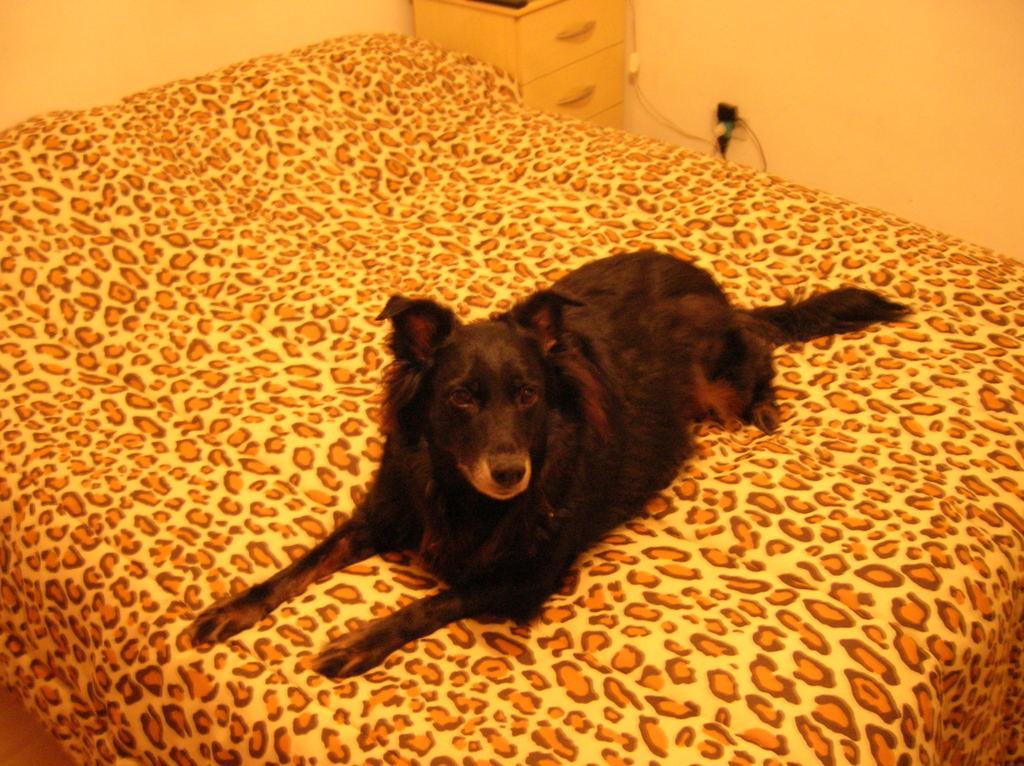Could you give a brief overview of what you see in this image? In the picture we can see a bed, on it we can see a dog which is black in color and in the background, we can see some draws and near it we can see some wires to the switchboard. 